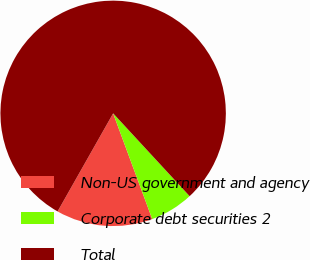<chart> <loc_0><loc_0><loc_500><loc_500><pie_chart><fcel>Non-US government and agency<fcel>Corporate debt securities 2<fcel>Total<nl><fcel>13.84%<fcel>6.23%<fcel>79.93%<nl></chart> 